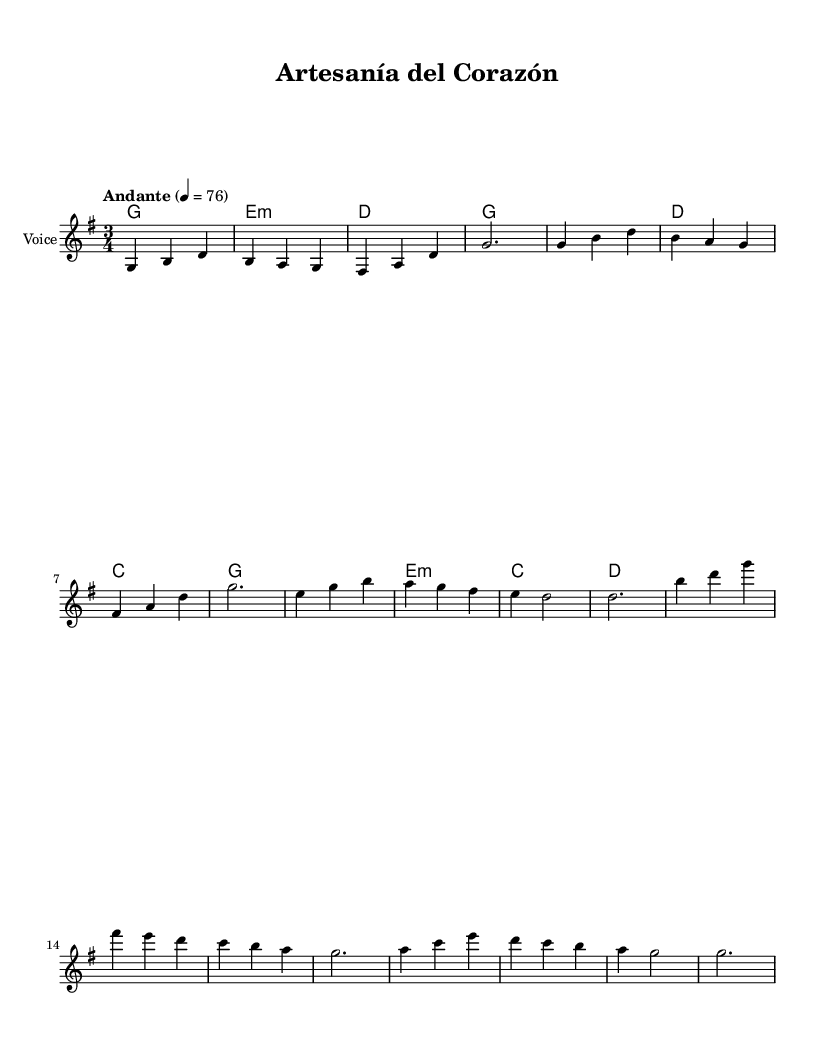What is the key signature of this music? The key signature is G major, which contains one sharp (F#). This can be identified from the key indication at the beginning of the score.
Answer: G major What is the time signature of this music? The time signature is 3/4, indicated at the start of the piece. This means there are three beats in each measure, with the quarter note getting the beat.
Answer: 3/4 What is the tempo marking for the piece? The tempo marking is "Andante," which translates to a moderately slow pace. This is also noted at the beginning of the score along with a metronome marking of 76.
Answer: Andante How many measures are in the chorus section? The chorus section has four measures, which can be counted from the music notation where the chorus is specified.
Answer: 4 What is the last chord of the progression in the chorus? The last chord in the chorus progression is D major, as indicated at the end of the chord sequence in this section.
Answer: D What words are associated with the first line of the verse? The first line of the verse contains the words "Con mis manos tejo sueños," which is written below the melody in the lyrics section.
Answer: Con mis manos tejo sueños How does the key change in the transition from verse to chorus? The key remains in G major during both the verse and chorus sections, which can be verified by the absence of any key signature changes throughout the piece.
Answer: No change 